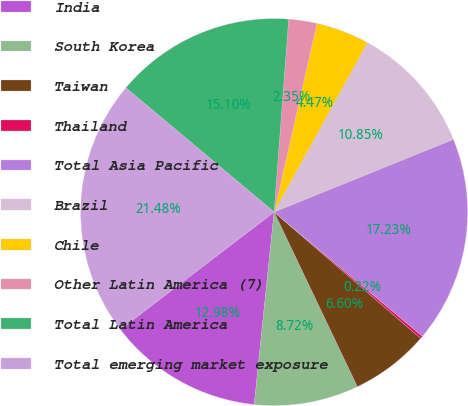<chart> <loc_0><loc_0><loc_500><loc_500><pie_chart><fcel>India<fcel>South Korea<fcel>Taiwan<fcel>Thailand<fcel>Total Asia Pacific<fcel>Brazil<fcel>Chile<fcel>Other Latin America (7)<fcel>Total Latin America<fcel>Total emerging market exposure<nl><fcel>12.98%<fcel>8.72%<fcel>6.6%<fcel>0.22%<fcel>17.23%<fcel>10.85%<fcel>4.47%<fcel>2.35%<fcel>15.1%<fcel>21.48%<nl></chart> 